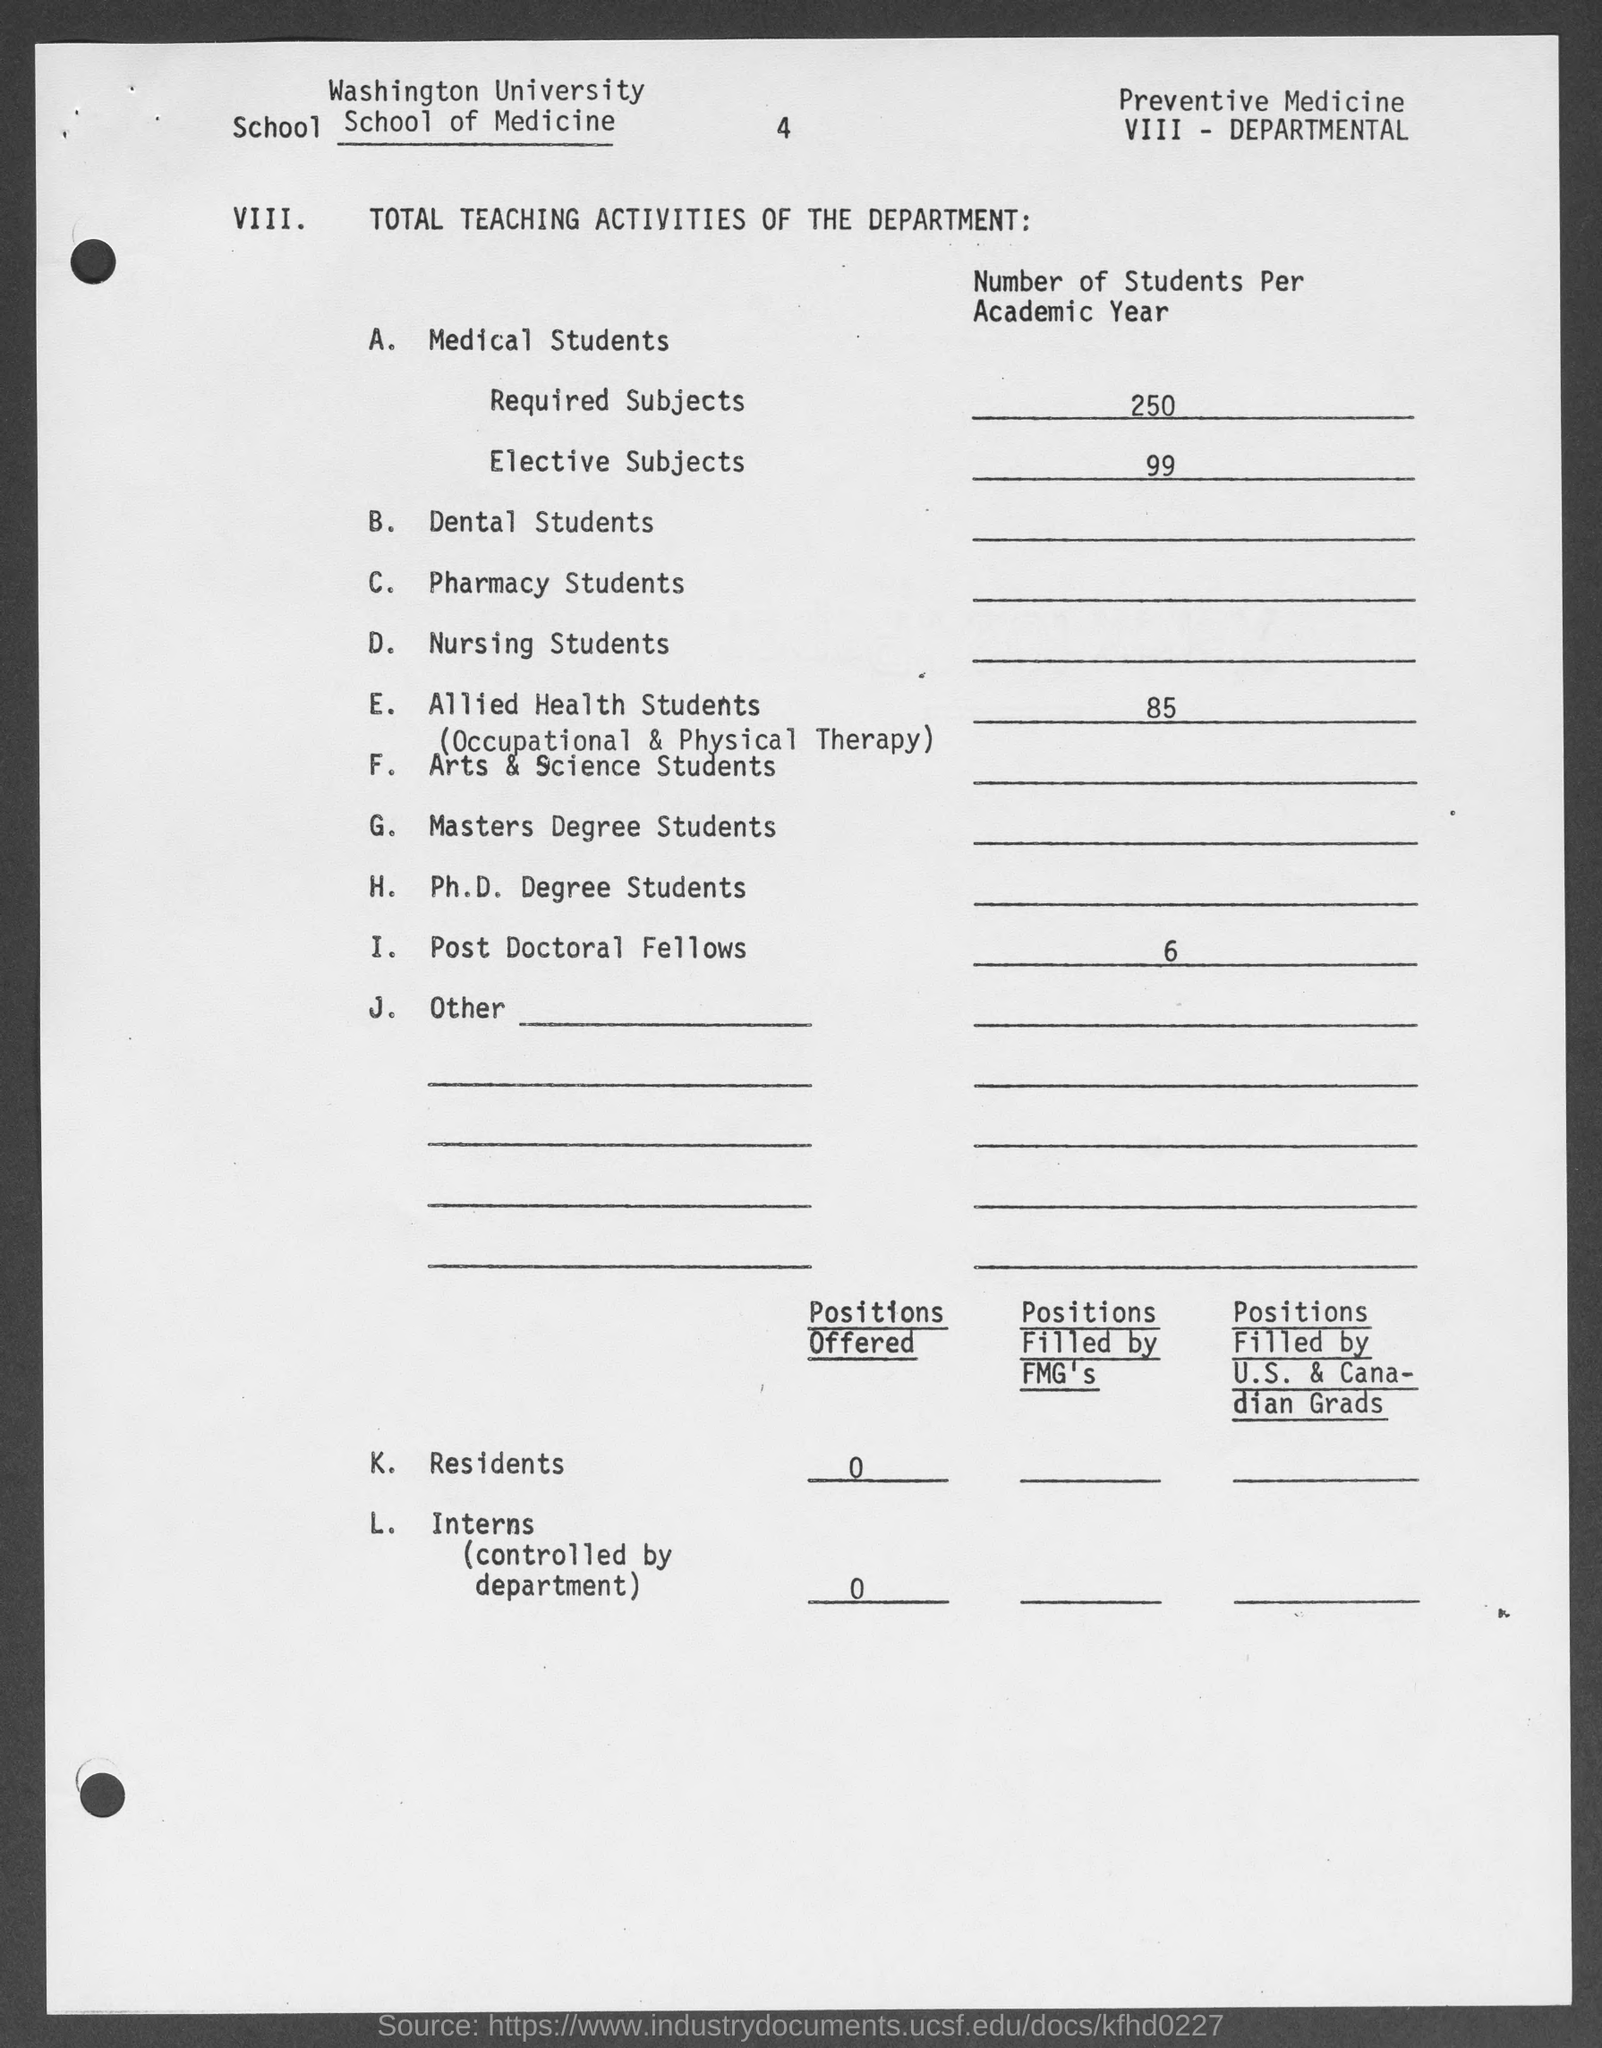Point out several critical features in this image. The number of required subjects for each academic year for 250 students has been specified in the given form. The number of positions offered by K. Residents, as mentioned in the given form, is not available. The value of elective subjects for the number of students per academic year as mentioned in the given form is 99. The name of the university mentioned in the given form is Washington University. 